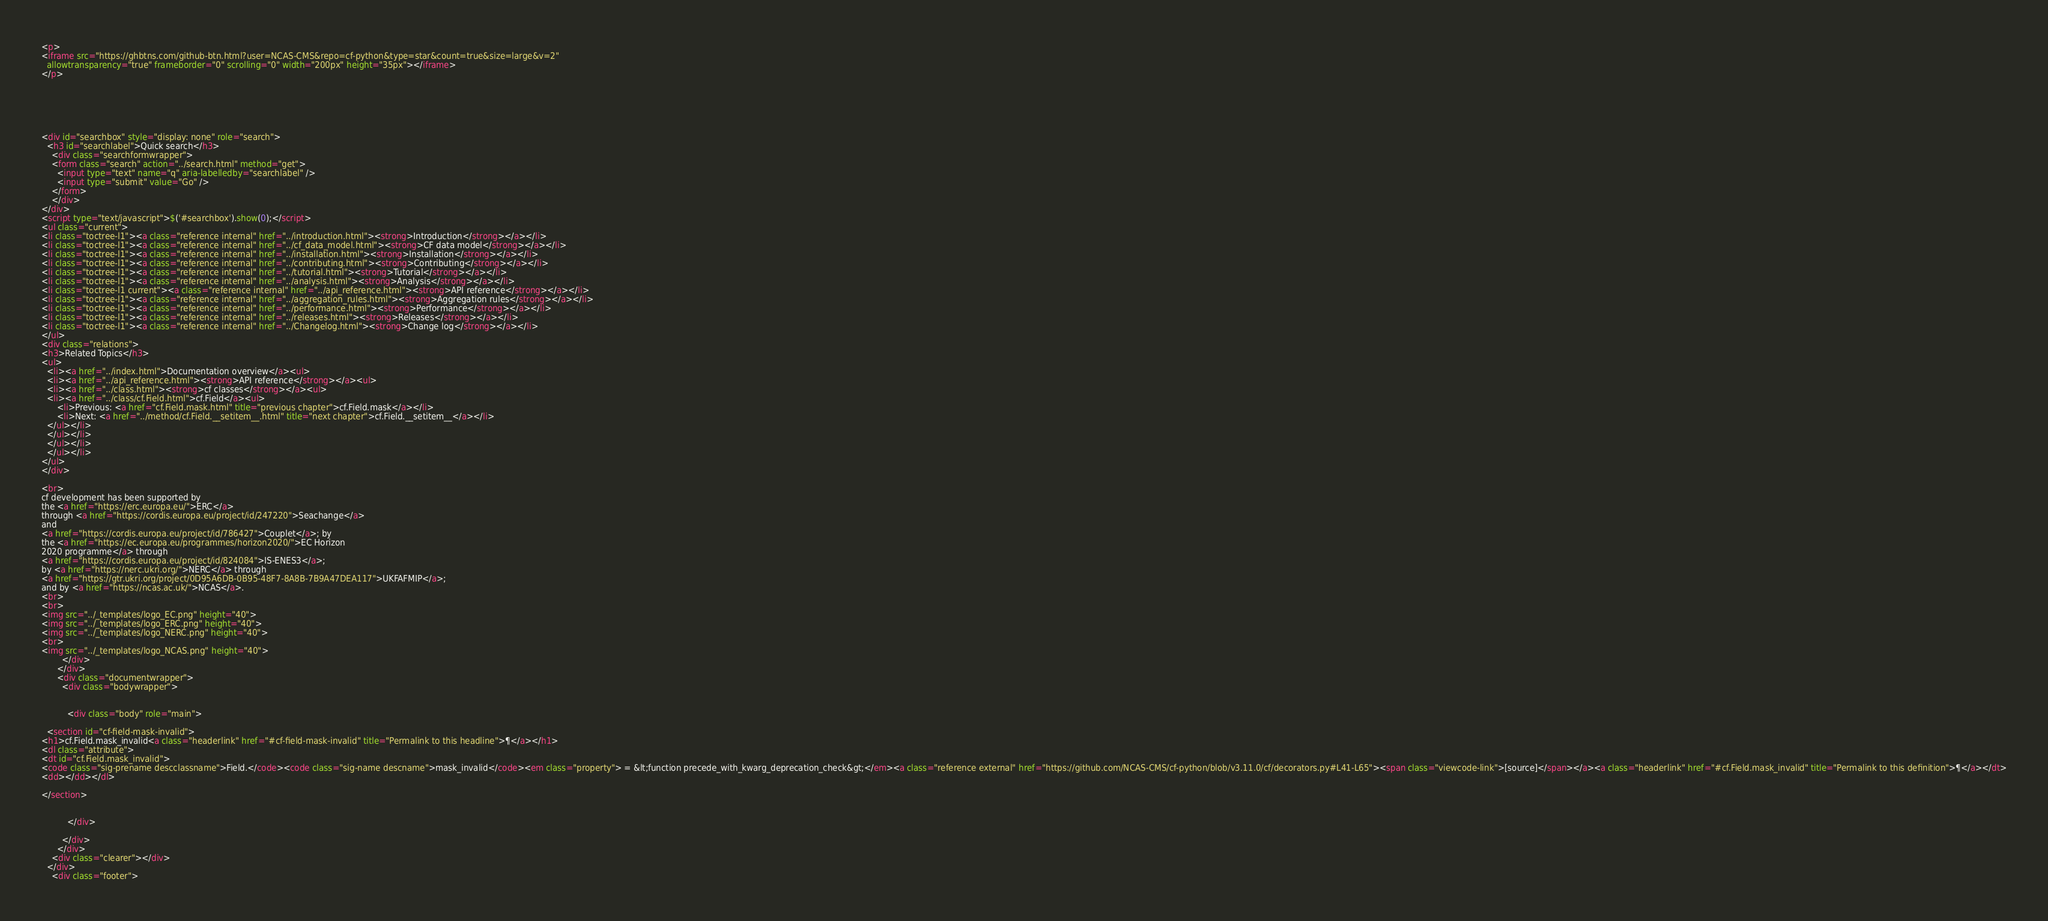Convert code to text. <code><loc_0><loc_0><loc_500><loc_500><_HTML_>



<p>
<iframe src="https://ghbtns.com/github-btn.html?user=NCAS-CMS&repo=cf-python&type=star&count=true&size=large&v=2"
  allowtransparency="true" frameborder="0" scrolling="0" width="200px" height="35px"></iframe>
</p>






<div id="searchbox" style="display: none" role="search">
  <h3 id="searchlabel">Quick search</h3>
    <div class="searchformwrapper">
    <form class="search" action="../search.html" method="get">
      <input type="text" name="q" aria-labelledby="searchlabel" />
      <input type="submit" value="Go" />
    </form>
    </div>
</div>
<script type="text/javascript">$('#searchbox').show(0);</script>
<ul class="current">
<li class="toctree-l1"><a class="reference internal" href="../introduction.html"><strong>Introduction</strong></a></li>
<li class="toctree-l1"><a class="reference internal" href="../cf_data_model.html"><strong>CF data model</strong></a></li>
<li class="toctree-l1"><a class="reference internal" href="../installation.html"><strong>Installation</strong></a></li>
<li class="toctree-l1"><a class="reference internal" href="../contributing.html"><strong>Contributing</strong></a></li>
<li class="toctree-l1"><a class="reference internal" href="../tutorial.html"><strong>Tutorial</strong></a></li>
<li class="toctree-l1"><a class="reference internal" href="../analysis.html"><strong>Analysis</strong></a></li>
<li class="toctree-l1 current"><a class="reference internal" href="../api_reference.html"><strong>API reference</strong></a></li>
<li class="toctree-l1"><a class="reference internal" href="../aggregation_rules.html"><strong>Aggregation rules</strong></a></li>
<li class="toctree-l1"><a class="reference internal" href="../performance.html"><strong>Performance</strong></a></li>
<li class="toctree-l1"><a class="reference internal" href="../releases.html"><strong>Releases</strong></a></li>
<li class="toctree-l1"><a class="reference internal" href="../Changelog.html"><strong>Change log</strong></a></li>
</ul>
<div class="relations">
<h3>Related Topics</h3>
<ul>
  <li><a href="../index.html">Documentation overview</a><ul>
  <li><a href="../api_reference.html"><strong>API reference</strong></a><ul>
  <li><a href="../class.html"><strong>cf classes</strong></a><ul>
  <li><a href="../class/cf.Field.html">cf.Field</a><ul>
      <li>Previous: <a href="cf.Field.mask.html" title="previous chapter">cf.Field.mask</a></li>
      <li>Next: <a href="../method/cf.Field.__setitem__.html" title="next chapter">cf.Field.__setitem__</a></li>
  </ul></li>
  </ul></li>
  </ul></li>
  </ul></li>
</ul>
</div>

<br>
cf development has been supported by
the <a href="https://erc.europa.eu/">ERC</a>
through <a href="https://cordis.europa.eu/project/id/247220">Seachange</a>
and
<a href="https://cordis.europa.eu/project/id/786427">Couplet</a>; by
the <a href="https://ec.europa.eu/programmes/horizon2020/">EC Horizon
2020 programme</a> through
<a href="https://cordis.europa.eu/project/id/824084">IS-ENES3</a>;
by <a href="https://nerc.ukri.org/">NERC</a> through
<a href="https://gtr.ukri.org/project/0D95A6DB-0B95-48F7-8A8B-7B9A47DEA117">UKFAFMIP</a>;
and by <a href="https://ncas.ac.uk/">NCAS</a>.
<br>
<br>
<img src="../_templates/logo_EC.png" height="40">
<img src="../_templates/logo_ERC.png" height="40">
<img src="../_templates/logo_NERC.png" height="40">
<br>
<img src="../_templates/logo_NCAS.png" height="40">
        </div>
      </div>
      <div class="documentwrapper">
        <div class="bodywrapper">
          

          <div class="body" role="main">
            
  <section id="cf-field-mask-invalid">
<h1>cf.Field.mask_invalid<a class="headerlink" href="#cf-field-mask-invalid" title="Permalink to this headline">¶</a></h1>
<dl class="attribute">
<dt id="cf.Field.mask_invalid">
<code class="sig-prename descclassname">Field.</code><code class="sig-name descname">mask_invalid</code><em class="property"> = &lt;function precede_with_kwarg_deprecation_check&gt;</em><a class="reference external" href="https://github.com/NCAS-CMS/cf-python/blob/v3.11.0/cf/decorators.py#L41-L65"><span class="viewcode-link">[source]</span></a><a class="headerlink" href="#cf.Field.mask_invalid" title="Permalink to this definition">¶</a></dt>
<dd></dd></dl>

</section>


          </div>
          
        </div>
      </div>
    <div class="clearer"></div>
  </div>
    <div class="footer"></code> 